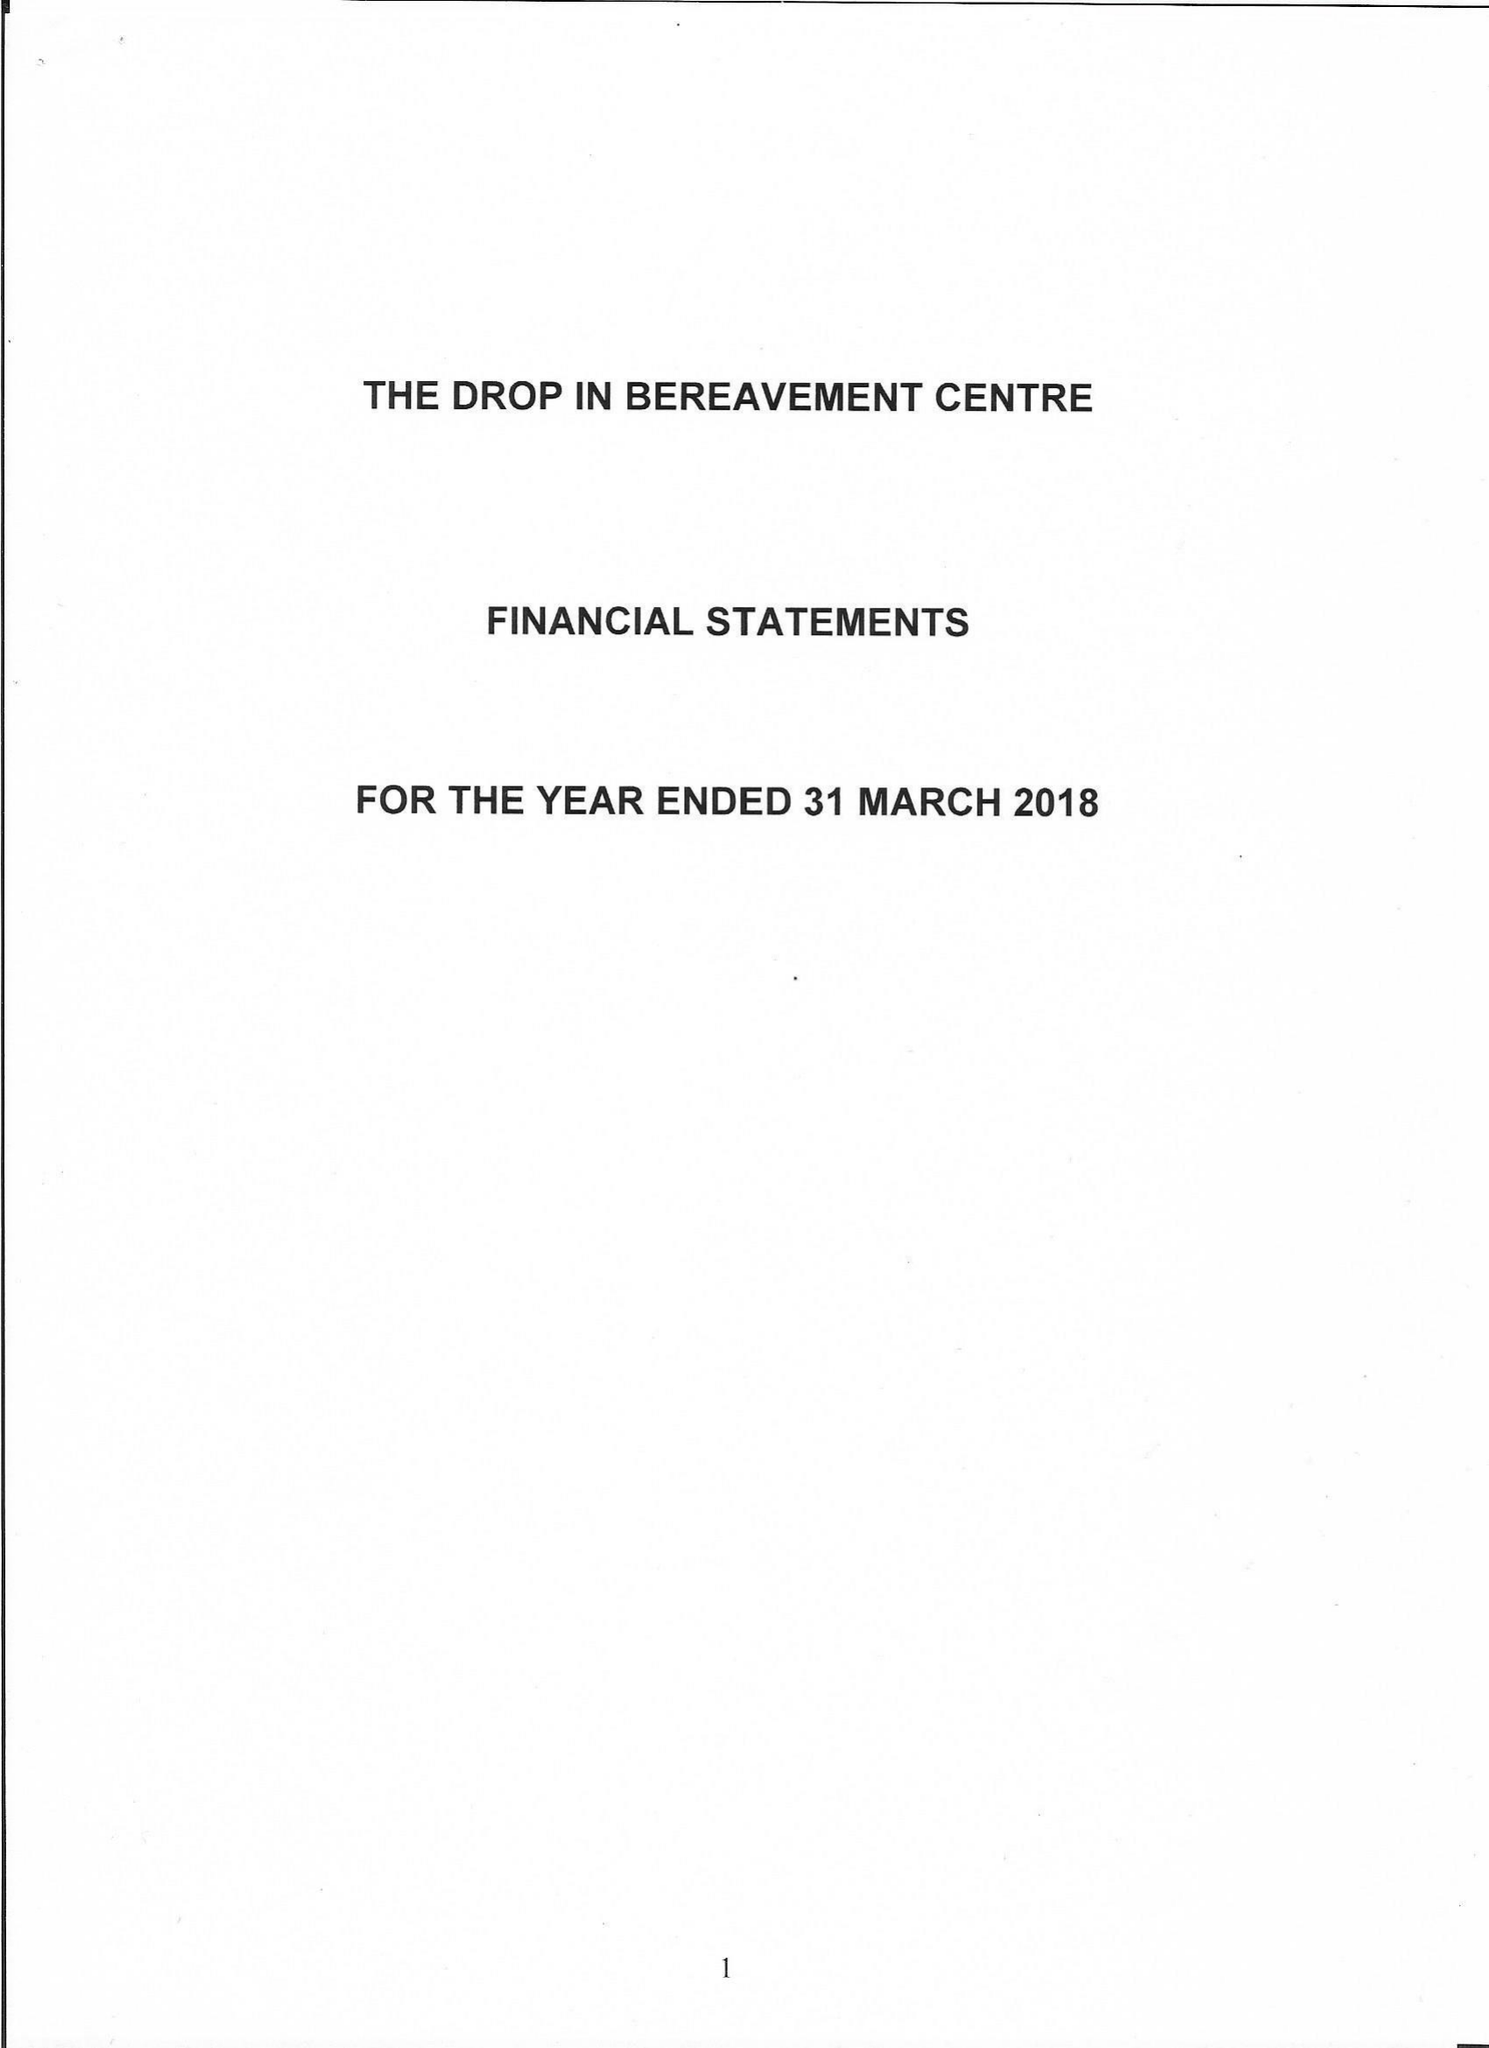What is the value for the spending_annually_in_british_pounds?
Answer the question using a single word or phrase. 24719.00 